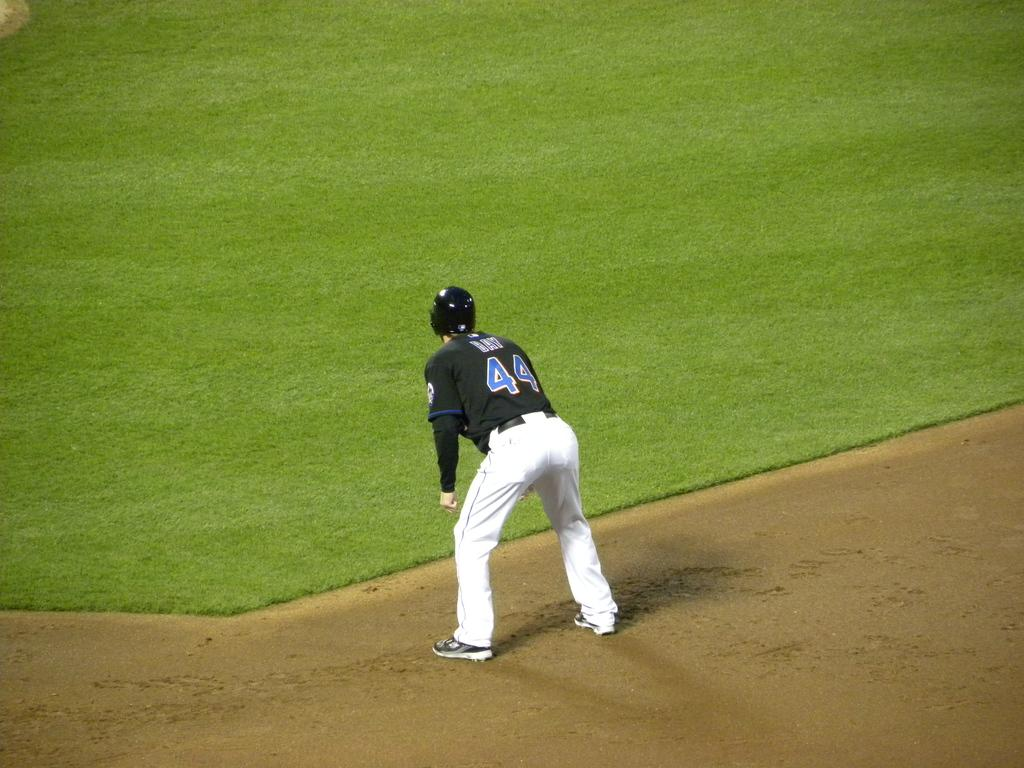<image>
Create a compact narrative representing the image presented. The number 44 wearing a black top and called Bay is waiting for the ball to come to him on the baseball field. 